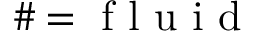Convert formula to latex. <formula><loc_0><loc_0><loc_500><loc_500>\# = f l u i d</formula> 